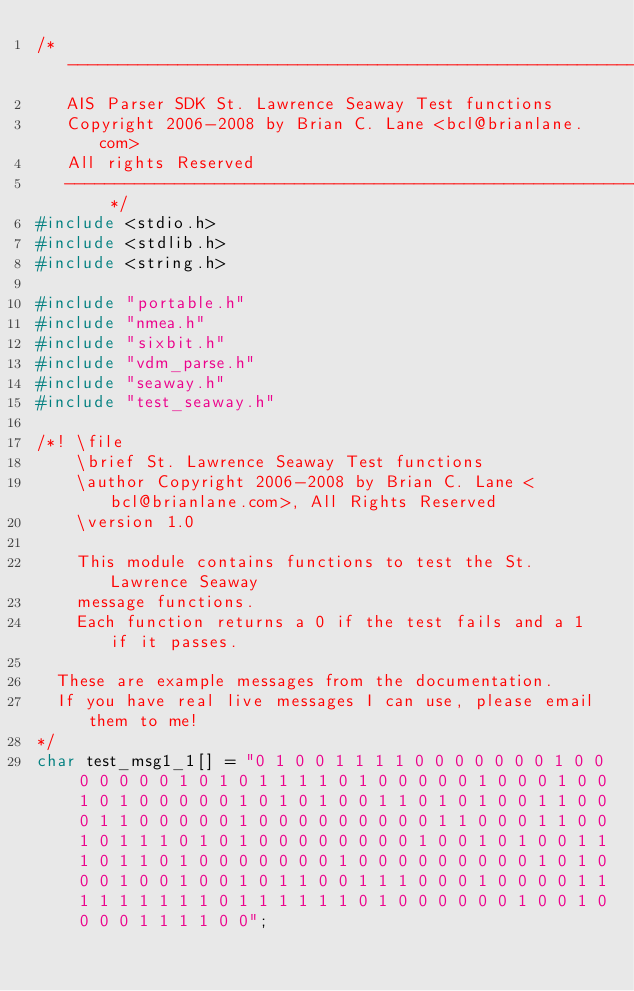Convert code to text. <code><loc_0><loc_0><loc_500><loc_500><_C_>/* -----------------------------------------------------------------------
   AIS Parser SDK St. Lawrence Seaway Test functions
   Copyright 2006-2008 by Brian C. Lane <bcl@brianlane.com>
   All rights Reserved
   ----------------------------------------------------------------------- */
#include <stdio.h>
#include <stdlib.h>
#include <string.h>

#include "portable.h"
#include "nmea.h"
#include "sixbit.h"
#include "vdm_parse.h"
#include "seaway.h"
#include "test_seaway.h"

/*! \file
    \brief St. Lawrence Seaway Test functions
    \author Copyright 2006-2008 by Brian C. Lane <bcl@brianlane.com>, All Rights Reserved
    \version 1.0

    This module contains functions to test the St. Lawrence Seaway
    message functions.
    Each function returns a 0 if the test fails and a 1 if it passes.

	These are example messages from the documentation.
	If you have real live messages I can use, please email them to me!
*/
char test_msg1_1[] = "0 1 0 0 1 1 1 1 0 0 0 0 0 0 0 1 0 0 0 0 0 0 0 1 0 1 0 1 1 1 1 0 1 0 0 0 0 0 1 0 0 0 1 0 0 1 0 1 0 0 0 0 0 1 0 1 0 1 0 0 1 1 0 1 0 1 0 0 1 1 0 0 0 1 1 0 0 0 0 0 1 0 0 0 0 0 0 0 0 0 1 1 0 0 0 1 1 0 0 1 0 1 1 1 0 1 0 1 0 0 0 0 0 0 0 0 1 0 0 1 0 1 0 0 1 1 1 0 1 1 0 1 0 0 0 0 0 0 0 1 0 0 0 0 0 0 0 0 0 1 0 1 0 0 0 1 0 0 1 0 0 1 0 1 1 0 0 1 1 1 0 0 0 1 0 0 0 0 1 1 1 1 1 1 1 1 1 0 1 1 1 1 1 1 0 1 0 0 0 0 0 0 1 0 0 1 0 0 0 0 1 1 1 1 0 0";</code> 